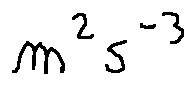<formula> <loc_0><loc_0><loc_500><loc_500>m ^ { 2 } s ^ { - 3 }</formula> 